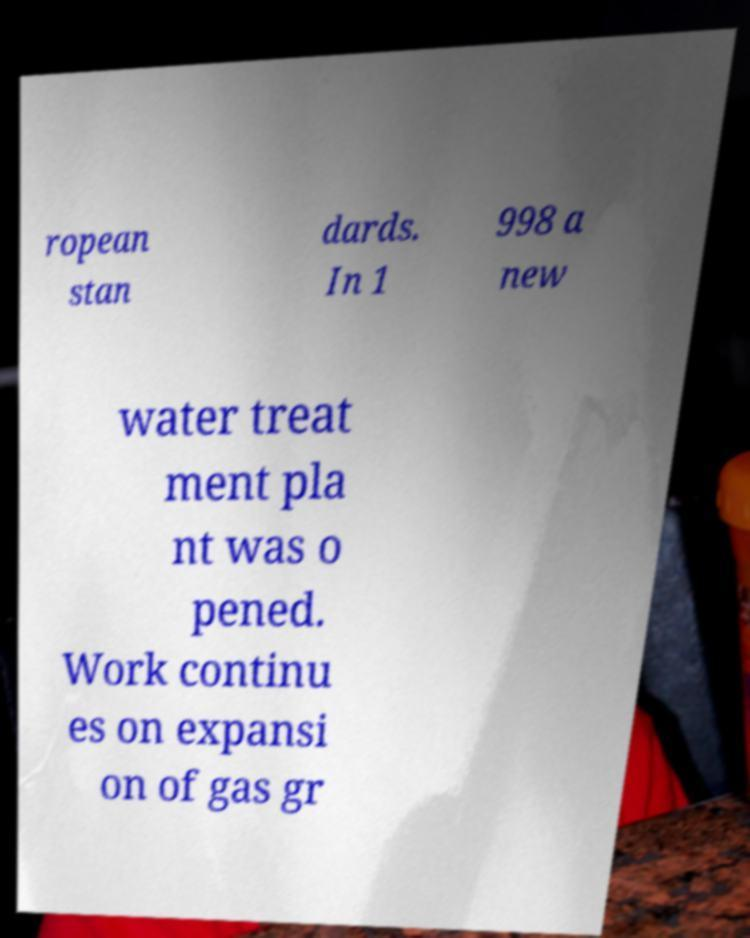Could you assist in decoding the text presented in this image and type it out clearly? ropean stan dards. In 1 998 a new water treat ment pla nt was o pened. Work continu es on expansi on of gas gr 